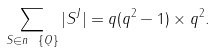<formula> <loc_0><loc_0><loc_500><loc_500>\sum _ { S \in n \ \{ Q \} } | S ^ { J } | = q ( q ^ { 2 } - 1 ) \times q ^ { 2 } .</formula> 